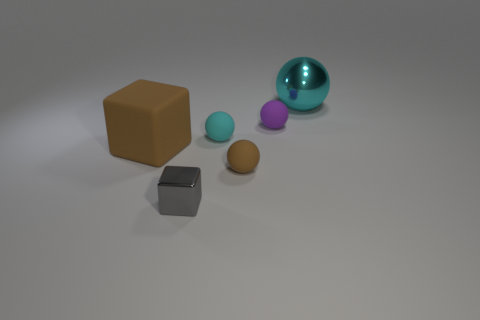What material do the objects in the image look like they are made of? The objects in the image appear to be made of various materials. The brown block looks like it could be made of a matte clay or plastic, the smaller spheres seem to be of a similar plastic material with a smooth finish, and the larger transparent blue sphere resembles glass or a transparent plastic. 